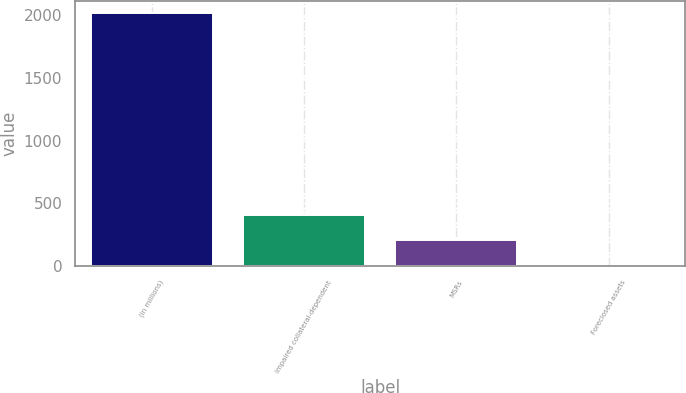<chart> <loc_0><loc_0><loc_500><loc_500><bar_chart><fcel>(in millions)<fcel>Impaired collateral-dependent<fcel>MSRs<fcel>Foreclosed assets<nl><fcel>2015<fcel>405.4<fcel>204.2<fcel>3<nl></chart> 